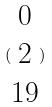Convert formula to latex. <formula><loc_0><loc_0><loc_500><loc_500>( \begin{matrix} 0 \\ 2 \\ 1 9 \end{matrix} )</formula> 